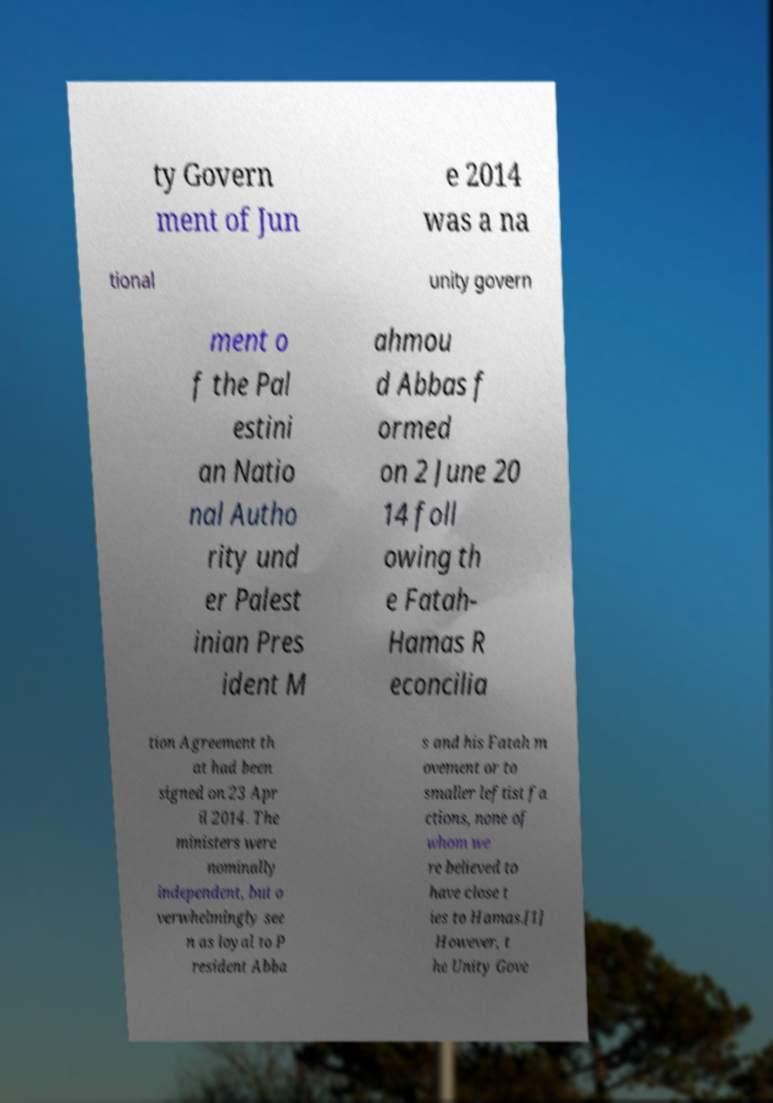I need the written content from this picture converted into text. Can you do that? ty Govern ment of Jun e 2014 was a na tional unity govern ment o f the Pal estini an Natio nal Autho rity und er Palest inian Pres ident M ahmou d Abbas f ormed on 2 June 20 14 foll owing th e Fatah- Hamas R econcilia tion Agreement th at had been signed on 23 Apr il 2014. The ministers were nominally independent, but o verwhelmingly see n as loyal to P resident Abba s and his Fatah m ovement or to smaller leftist fa ctions, none of whom we re believed to have close t ies to Hamas.[1] However, t he Unity Gove 